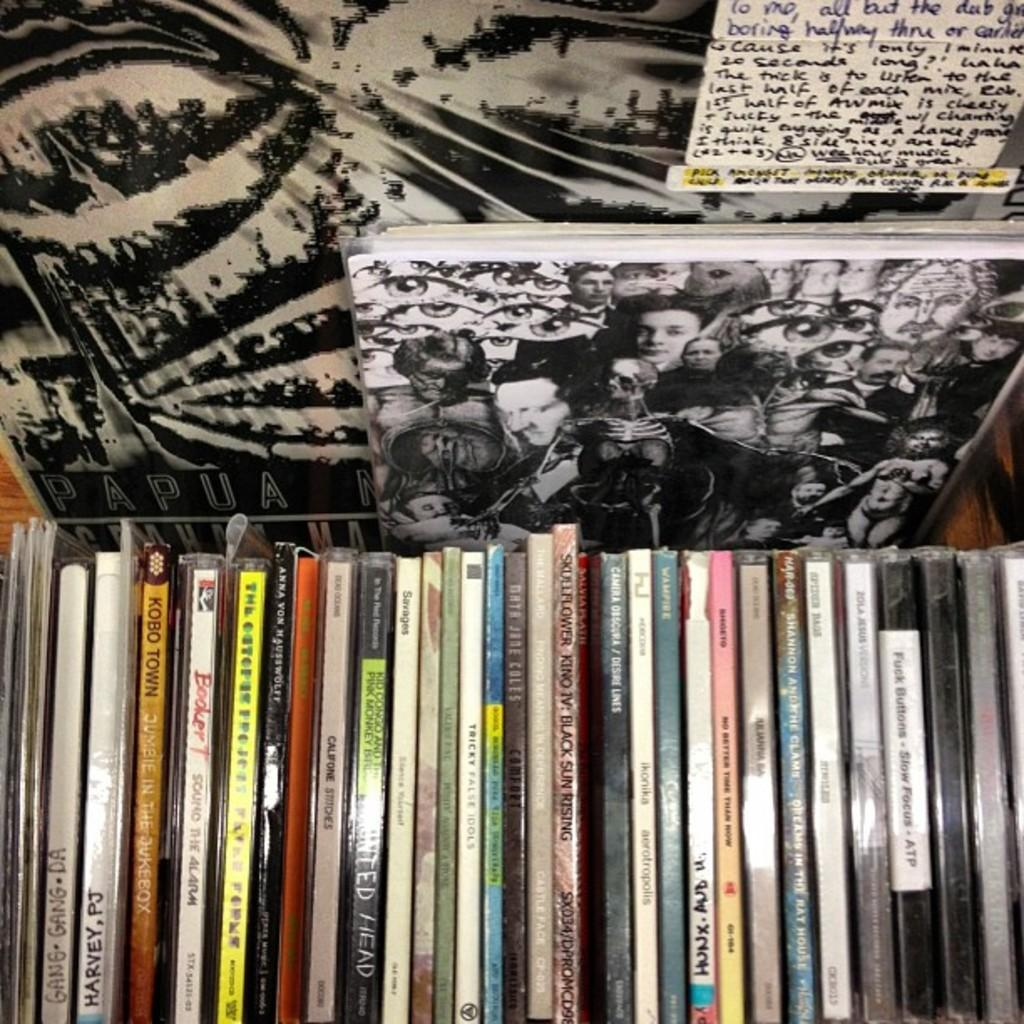Provide a one-sentence caption for the provided image. A bunch of CD's are stacked side by side with PJ Harvey and Skullflower being a few. 